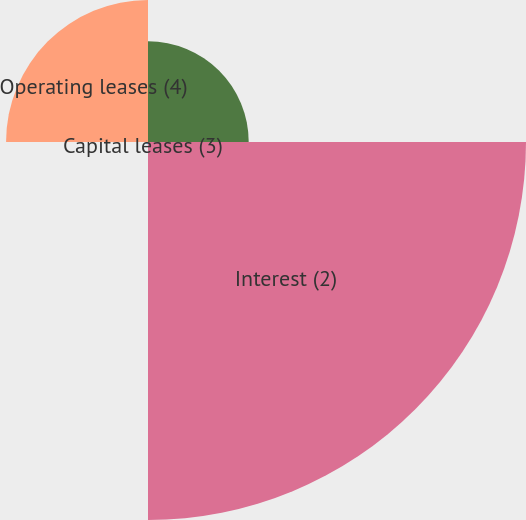Convert chart to OTSL. <chart><loc_0><loc_0><loc_500><loc_500><pie_chart><fcel>Principal<fcel>Interest (2)<fcel>Capital leases (3)<fcel>Operating leases (4)<nl><fcel>16.16%<fcel>60.66%<fcel>0.4%<fcel>22.78%<nl></chart> 